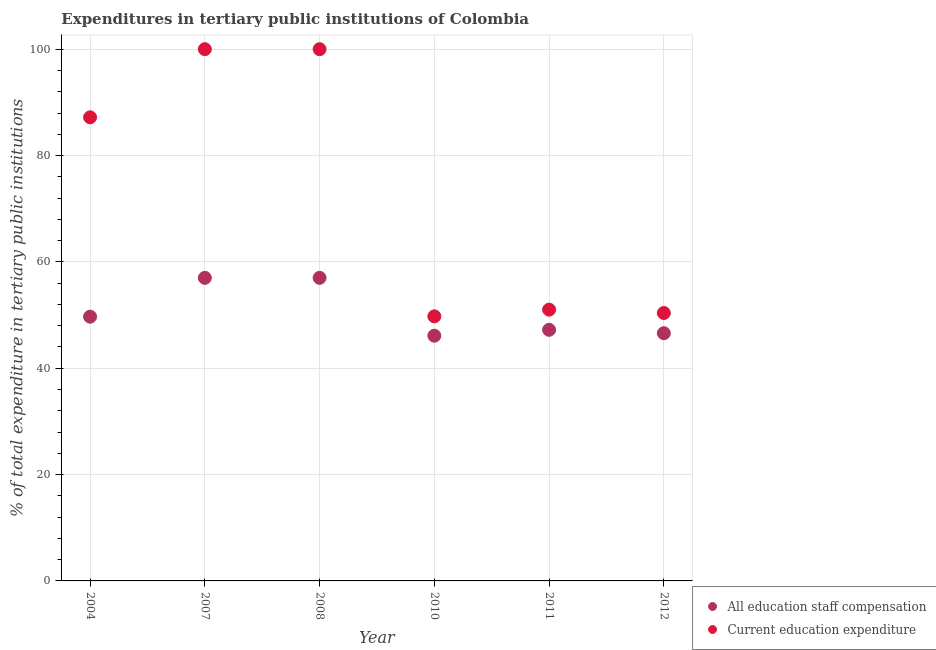Is the number of dotlines equal to the number of legend labels?
Offer a very short reply. Yes. What is the expenditure in staff compensation in 2007?
Your answer should be compact. 57. Across all years, what is the maximum expenditure in staff compensation?
Your response must be concise. 57. Across all years, what is the minimum expenditure in staff compensation?
Your answer should be compact. 46.12. In which year was the expenditure in education minimum?
Your answer should be very brief. 2010. What is the total expenditure in staff compensation in the graph?
Offer a very short reply. 303.62. What is the difference between the expenditure in staff compensation in 2007 and that in 2012?
Provide a short and direct response. 10.41. What is the difference between the expenditure in staff compensation in 2007 and the expenditure in education in 2012?
Offer a very short reply. 6.61. What is the average expenditure in staff compensation per year?
Ensure brevity in your answer.  50.6. In the year 2008, what is the difference between the expenditure in staff compensation and expenditure in education?
Provide a short and direct response. -43. In how many years, is the expenditure in staff compensation greater than 68 %?
Your response must be concise. 0. What is the ratio of the expenditure in education in 2007 to that in 2011?
Offer a terse response. 1.96. Is the expenditure in education in 2004 less than that in 2012?
Provide a short and direct response. No. What is the difference between the highest and the lowest expenditure in staff compensation?
Offer a very short reply. 10.88. Is the expenditure in staff compensation strictly less than the expenditure in education over the years?
Your answer should be compact. Yes. How many years are there in the graph?
Your answer should be compact. 6. What is the difference between two consecutive major ticks on the Y-axis?
Your answer should be very brief. 20. Does the graph contain any zero values?
Your response must be concise. No. Does the graph contain grids?
Provide a succinct answer. Yes. How many legend labels are there?
Your answer should be compact. 2. What is the title of the graph?
Offer a very short reply. Expenditures in tertiary public institutions of Colombia. What is the label or title of the Y-axis?
Your response must be concise. % of total expenditure in tertiary public institutions. What is the % of total expenditure in tertiary public institutions of All education staff compensation in 2004?
Provide a short and direct response. 49.7. What is the % of total expenditure in tertiary public institutions in Current education expenditure in 2004?
Give a very brief answer. 87.19. What is the % of total expenditure in tertiary public institutions of All education staff compensation in 2007?
Make the answer very short. 57. What is the % of total expenditure in tertiary public institutions in All education staff compensation in 2008?
Give a very brief answer. 57. What is the % of total expenditure in tertiary public institutions in Current education expenditure in 2008?
Ensure brevity in your answer.  100. What is the % of total expenditure in tertiary public institutions of All education staff compensation in 2010?
Keep it short and to the point. 46.12. What is the % of total expenditure in tertiary public institutions in Current education expenditure in 2010?
Offer a very short reply. 49.76. What is the % of total expenditure in tertiary public institutions of All education staff compensation in 2011?
Provide a succinct answer. 47.23. What is the % of total expenditure in tertiary public institutions in Current education expenditure in 2011?
Your response must be concise. 51.02. What is the % of total expenditure in tertiary public institutions in All education staff compensation in 2012?
Offer a terse response. 46.59. What is the % of total expenditure in tertiary public institutions of Current education expenditure in 2012?
Your answer should be very brief. 50.39. Across all years, what is the maximum % of total expenditure in tertiary public institutions of All education staff compensation?
Provide a short and direct response. 57. Across all years, what is the minimum % of total expenditure in tertiary public institutions of All education staff compensation?
Keep it short and to the point. 46.12. Across all years, what is the minimum % of total expenditure in tertiary public institutions in Current education expenditure?
Make the answer very short. 49.76. What is the total % of total expenditure in tertiary public institutions in All education staff compensation in the graph?
Your answer should be compact. 303.62. What is the total % of total expenditure in tertiary public institutions of Current education expenditure in the graph?
Give a very brief answer. 438.36. What is the difference between the % of total expenditure in tertiary public institutions of All education staff compensation in 2004 and that in 2007?
Provide a short and direct response. -7.3. What is the difference between the % of total expenditure in tertiary public institutions in Current education expenditure in 2004 and that in 2007?
Your answer should be very brief. -12.81. What is the difference between the % of total expenditure in tertiary public institutions in All education staff compensation in 2004 and that in 2008?
Ensure brevity in your answer.  -7.3. What is the difference between the % of total expenditure in tertiary public institutions of Current education expenditure in 2004 and that in 2008?
Keep it short and to the point. -12.81. What is the difference between the % of total expenditure in tertiary public institutions in All education staff compensation in 2004 and that in 2010?
Provide a short and direct response. 3.58. What is the difference between the % of total expenditure in tertiary public institutions in Current education expenditure in 2004 and that in 2010?
Your response must be concise. 37.43. What is the difference between the % of total expenditure in tertiary public institutions in All education staff compensation in 2004 and that in 2011?
Make the answer very short. 2.47. What is the difference between the % of total expenditure in tertiary public institutions in Current education expenditure in 2004 and that in 2011?
Provide a succinct answer. 36.17. What is the difference between the % of total expenditure in tertiary public institutions of All education staff compensation in 2004 and that in 2012?
Provide a succinct answer. 3.11. What is the difference between the % of total expenditure in tertiary public institutions in Current education expenditure in 2004 and that in 2012?
Your answer should be very brief. 36.8. What is the difference between the % of total expenditure in tertiary public institutions in All education staff compensation in 2007 and that in 2010?
Offer a terse response. 10.88. What is the difference between the % of total expenditure in tertiary public institutions of Current education expenditure in 2007 and that in 2010?
Your response must be concise. 50.24. What is the difference between the % of total expenditure in tertiary public institutions of All education staff compensation in 2007 and that in 2011?
Ensure brevity in your answer.  9.77. What is the difference between the % of total expenditure in tertiary public institutions of Current education expenditure in 2007 and that in 2011?
Offer a terse response. 48.98. What is the difference between the % of total expenditure in tertiary public institutions in All education staff compensation in 2007 and that in 2012?
Make the answer very short. 10.41. What is the difference between the % of total expenditure in tertiary public institutions of Current education expenditure in 2007 and that in 2012?
Your answer should be compact. 49.61. What is the difference between the % of total expenditure in tertiary public institutions in All education staff compensation in 2008 and that in 2010?
Keep it short and to the point. 10.88. What is the difference between the % of total expenditure in tertiary public institutions of Current education expenditure in 2008 and that in 2010?
Make the answer very short. 50.24. What is the difference between the % of total expenditure in tertiary public institutions in All education staff compensation in 2008 and that in 2011?
Your answer should be compact. 9.77. What is the difference between the % of total expenditure in tertiary public institutions of Current education expenditure in 2008 and that in 2011?
Your answer should be very brief. 48.98. What is the difference between the % of total expenditure in tertiary public institutions in All education staff compensation in 2008 and that in 2012?
Ensure brevity in your answer.  10.41. What is the difference between the % of total expenditure in tertiary public institutions in Current education expenditure in 2008 and that in 2012?
Offer a terse response. 49.61. What is the difference between the % of total expenditure in tertiary public institutions in All education staff compensation in 2010 and that in 2011?
Provide a short and direct response. -1.11. What is the difference between the % of total expenditure in tertiary public institutions in Current education expenditure in 2010 and that in 2011?
Give a very brief answer. -1.26. What is the difference between the % of total expenditure in tertiary public institutions in All education staff compensation in 2010 and that in 2012?
Ensure brevity in your answer.  -0.47. What is the difference between the % of total expenditure in tertiary public institutions in Current education expenditure in 2010 and that in 2012?
Provide a short and direct response. -0.63. What is the difference between the % of total expenditure in tertiary public institutions of All education staff compensation in 2011 and that in 2012?
Give a very brief answer. 0.64. What is the difference between the % of total expenditure in tertiary public institutions of Current education expenditure in 2011 and that in 2012?
Provide a succinct answer. 0.63. What is the difference between the % of total expenditure in tertiary public institutions of All education staff compensation in 2004 and the % of total expenditure in tertiary public institutions of Current education expenditure in 2007?
Your answer should be very brief. -50.3. What is the difference between the % of total expenditure in tertiary public institutions of All education staff compensation in 2004 and the % of total expenditure in tertiary public institutions of Current education expenditure in 2008?
Keep it short and to the point. -50.3. What is the difference between the % of total expenditure in tertiary public institutions of All education staff compensation in 2004 and the % of total expenditure in tertiary public institutions of Current education expenditure in 2010?
Your answer should be very brief. -0.06. What is the difference between the % of total expenditure in tertiary public institutions of All education staff compensation in 2004 and the % of total expenditure in tertiary public institutions of Current education expenditure in 2011?
Provide a short and direct response. -1.32. What is the difference between the % of total expenditure in tertiary public institutions in All education staff compensation in 2004 and the % of total expenditure in tertiary public institutions in Current education expenditure in 2012?
Your answer should be compact. -0.69. What is the difference between the % of total expenditure in tertiary public institutions in All education staff compensation in 2007 and the % of total expenditure in tertiary public institutions in Current education expenditure in 2008?
Provide a succinct answer. -43. What is the difference between the % of total expenditure in tertiary public institutions in All education staff compensation in 2007 and the % of total expenditure in tertiary public institutions in Current education expenditure in 2010?
Give a very brief answer. 7.24. What is the difference between the % of total expenditure in tertiary public institutions in All education staff compensation in 2007 and the % of total expenditure in tertiary public institutions in Current education expenditure in 2011?
Your answer should be compact. 5.98. What is the difference between the % of total expenditure in tertiary public institutions in All education staff compensation in 2007 and the % of total expenditure in tertiary public institutions in Current education expenditure in 2012?
Offer a very short reply. 6.61. What is the difference between the % of total expenditure in tertiary public institutions in All education staff compensation in 2008 and the % of total expenditure in tertiary public institutions in Current education expenditure in 2010?
Give a very brief answer. 7.24. What is the difference between the % of total expenditure in tertiary public institutions in All education staff compensation in 2008 and the % of total expenditure in tertiary public institutions in Current education expenditure in 2011?
Keep it short and to the point. 5.98. What is the difference between the % of total expenditure in tertiary public institutions of All education staff compensation in 2008 and the % of total expenditure in tertiary public institutions of Current education expenditure in 2012?
Ensure brevity in your answer.  6.61. What is the difference between the % of total expenditure in tertiary public institutions in All education staff compensation in 2010 and the % of total expenditure in tertiary public institutions in Current education expenditure in 2011?
Give a very brief answer. -4.9. What is the difference between the % of total expenditure in tertiary public institutions in All education staff compensation in 2010 and the % of total expenditure in tertiary public institutions in Current education expenditure in 2012?
Give a very brief answer. -4.27. What is the difference between the % of total expenditure in tertiary public institutions of All education staff compensation in 2011 and the % of total expenditure in tertiary public institutions of Current education expenditure in 2012?
Make the answer very short. -3.16. What is the average % of total expenditure in tertiary public institutions of All education staff compensation per year?
Offer a very short reply. 50.6. What is the average % of total expenditure in tertiary public institutions in Current education expenditure per year?
Provide a short and direct response. 73.06. In the year 2004, what is the difference between the % of total expenditure in tertiary public institutions in All education staff compensation and % of total expenditure in tertiary public institutions in Current education expenditure?
Make the answer very short. -37.49. In the year 2007, what is the difference between the % of total expenditure in tertiary public institutions in All education staff compensation and % of total expenditure in tertiary public institutions in Current education expenditure?
Make the answer very short. -43. In the year 2008, what is the difference between the % of total expenditure in tertiary public institutions of All education staff compensation and % of total expenditure in tertiary public institutions of Current education expenditure?
Offer a very short reply. -43. In the year 2010, what is the difference between the % of total expenditure in tertiary public institutions of All education staff compensation and % of total expenditure in tertiary public institutions of Current education expenditure?
Offer a terse response. -3.64. In the year 2011, what is the difference between the % of total expenditure in tertiary public institutions of All education staff compensation and % of total expenditure in tertiary public institutions of Current education expenditure?
Your answer should be compact. -3.79. In the year 2012, what is the difference between the % of total expenditure in tertiary public institutions in All education staff compensation and % of total expenditure in tertiary public institutions in Current education expenditure?
Your answer should be compact. -3.8. What is the ratio of the % of total expenditure in tertiary public institutions in All education staff compensation in 2004 to that in 2007?
Keep it short and to the point. 0.87. What is the ratio of the % of total expenditure in tertiary public institutions in Current education expenditure in 2004 to that in 2007?
Make the answer very short. 0.87. What is the ratio of the % of total expenditure in tertiary public institutions in All education staff compensation in 2004 to that in 2008?
Make the answer very short. 0.87. What is the ratio of the % of total expenditure in tertiary public institutions of Current education expenditure in 2004 to that in 2008?
Your answer should be very brief. 0.87. What is the ratio of the % of total expenditure in tertiary public institutions of All education staff compensation in 2004 to that in 2010?
Your response must be concise. 1.08. What is the ratio of the % of total expenditure in tertiary public institutions of Current education expenditure in 2004 to that in 2010?
Provide a succinct answer. 1.75. What is the ratio of the % of total expenditure in tertiary public institutions in All education staff compensation in 2004 to that in 2011?
Your response must be concise. 1.05. What is the ratio of the % of total expenditure in tertiary public institutions in Current education expenditure in 2004 to that in 2011?
Keep it short and to the point. 1.71. What is the ratio of the % of total expenditure in tertiary public institutions in All education staff compensation in 2004 to that in 2012?
Give a very brief answer. 1.07. What is the ratio of the % of total expenditure in tertiary public institutions of Current education expenditure in 2004 to that in 2012?
Provide a succinct answer. 1.73. What is the ratio of the % of total expenditure in tertiary public institutions of All education staff compensation in 2007 to that in 2010?
Your answer should be very brief. 1.24. What is the ratio of the % of total expenditure in tertiary public institutions in Current education expenditure in 2007 to that in 2010?
Make the answer very short. 2.01. What is the ratio of the % of total expenditure in tertiary public institutions of All education staff compensation in 2007 to that in 2011?
Give a very brief answer. 1.21. What is the ratio of the % of total expenditure in tertiary public institutions of Current education expenditure in 2007 to that in 2011?
Make the answer very short. 1.96. What is the ratio of the % of total expenditure in tertiary public institutions of All education staff compensation in 2007 to that in 2012?
Your answer should be very brief. 1.22. What is the ratio of the % of total expenditure in tertiary public institutions in Current education expenditure in 2007 to that in 2012?
Ensure brevity in your answer.  1.98. What is the ratio of the % of total expenditure in tertiary public institutions in All education staff compensation in 2008 to that in 2010?
Ensure brevity in your answer.  1.24. What is the ratio of the % of total expenditure in tertiary public institutions of Current education expenditure in 2008 to that in 2010?
Your response must be concise. 2.01. What is the ratio of the % of total expenditure in tertiary public institutions of All education staff compensation in 2008 to that in 2011?
Provide a succinct answer. 1.21. What is the ratio of the % of total expenditure in tertiary public institutions in Current education expenditure in 2008 to that in 2011?
Provide a succinct answer. 1.96. What is the ratio of the % of total expenditure in tertiary public institutions in All education staff compensation in 2008 to that in 2012?
Your response must be concise. 1.22. What is the ratio of the % of total expenditure in tertiary public institutions in Current education expenditure in 2008 to that in 2012?
Your answer should be compact. 1.98. What is the ratio of the % of total expenditure in tertiary public institutions in All education staff compensation in 2010 to that in 2011?
Provide a short and direct response. 0.98. What is the ratio of the % of total expenditure in tertiary public institutions of Current education expenditure in 2010 to that in 2011?
Offer a very short reply. 0.98. What is the ratio of the % of total expenditure in tertiary public institutions of Current education expenditure in 2010 to that in 2012?
Your answer should be compact. 0.99. What is the ratio of the % of total expenditure in tertiary public institutions in All education staff compensation in 2011 to that in 2012?
Make the answer very short. 1.01. What is the ratio of the % of total expenditure in tertiary public institutions in Current education expenditure in 2011 to that in 2012?
Your answer should be very brief. 1.01. What is the difference between the highest and the lowest % of total expenditure in tertiary public institutions in All education staff compensation?
Give a very brief answer. 10.88. What is the difference between the highest and the lowest % of total expenditure in tertiary public institutions of Current education expenditure?
Keep it short and to the point. 50.24. 